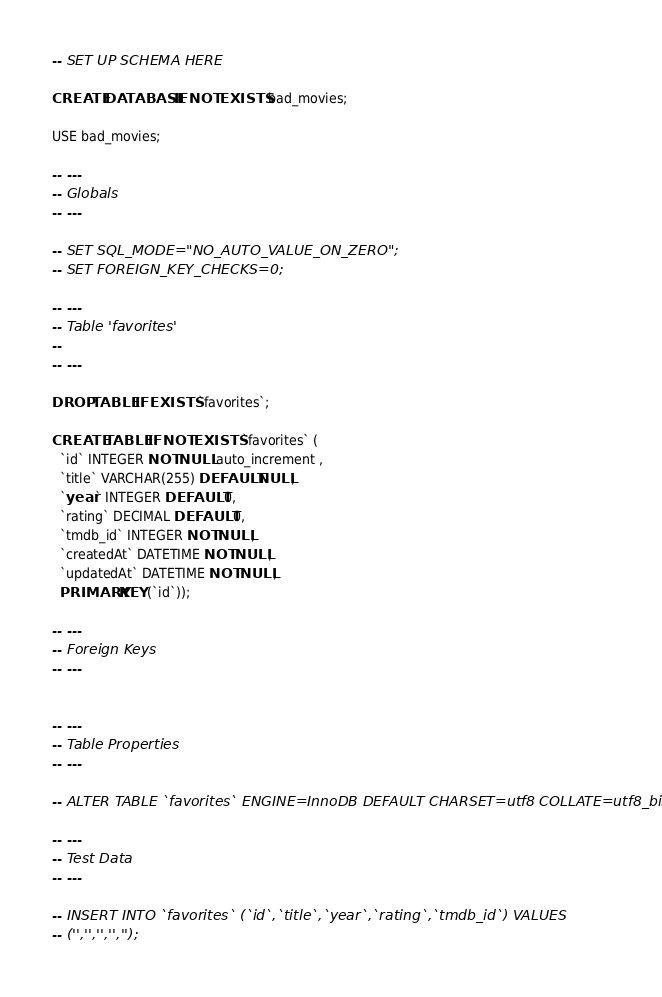<code> <loc_0><loc_0><loc_500><loc_500><_SQL_>-- SET UP SCHEMA HERE

CREATE DATABASE IF NOT EXISTS bad_movies;

USE bad_movies;

-- ---
-- Globals
-- ---

-- SET SQL_MODE="NO_AUTO_VALUE_ON_ZERO";
-- SET FOREIGN_KEY_CHECKS=0;

-- ---
-- Table 'favorites'
-- 
-- ---

DROP TABLE IF EXISTS `favorites`;
		
CREATE TABLE IF NOT EXISTS `favorites` (
  `id` INTEGER NOT NULL auto_increment , 
  `title` VARCHAR(255) DEFAULT NULL, 
  `year` INTEGER DEFAULT 0, 
  `rating` DECIMAL DEFAULT 0, 
  `tmdb_id` INTEGER NOT NULL, 
  `createdAt` DATETIME NOT NULL, 
  `updatedAt` DATETIME NOT NULL, 
  PRIMARY KEY (`id`));

-- ---
-- Foreign Keys 
-- ---


-- ---
-- Table Properties
-- ---

-- ALTER TABLE `favorites` ENGINE=InnoDB DEFAULT CHARSET=utf8 COLLATE=utf8_bin;

-- ---
-- Test Data
-- ---

-- INSERT INTO `favorites` (`id`,`title`,`year`,`rating`,`tmdb_id`) VALUES
-- ('','','','','');</code> 